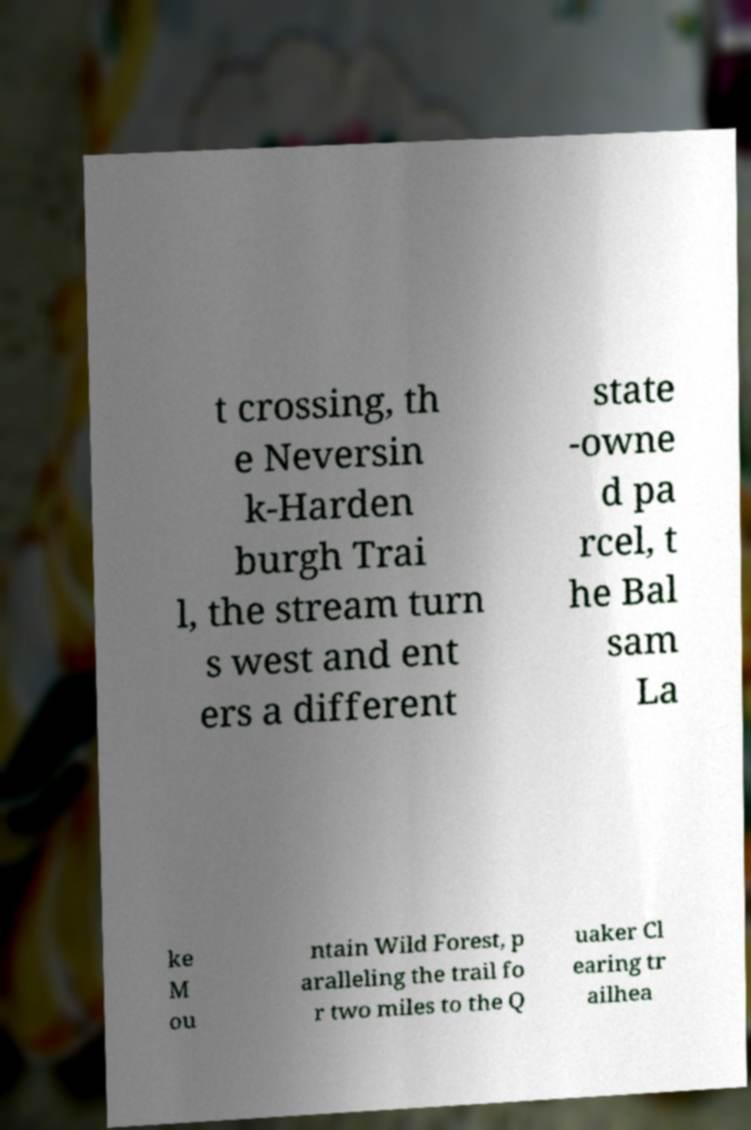Could you assist in decoding the text presented in this image and type it out clearly? t crossing, th e Neversin k-Harden burgh Trai l, the stream turn s west and ent ers a different state -owne d pa rcel, t he Bal sam La ke M ou ntain Wild Forest, p aralleling the trail fo r two miles to the Q uaker Cl earing tr ailhea 